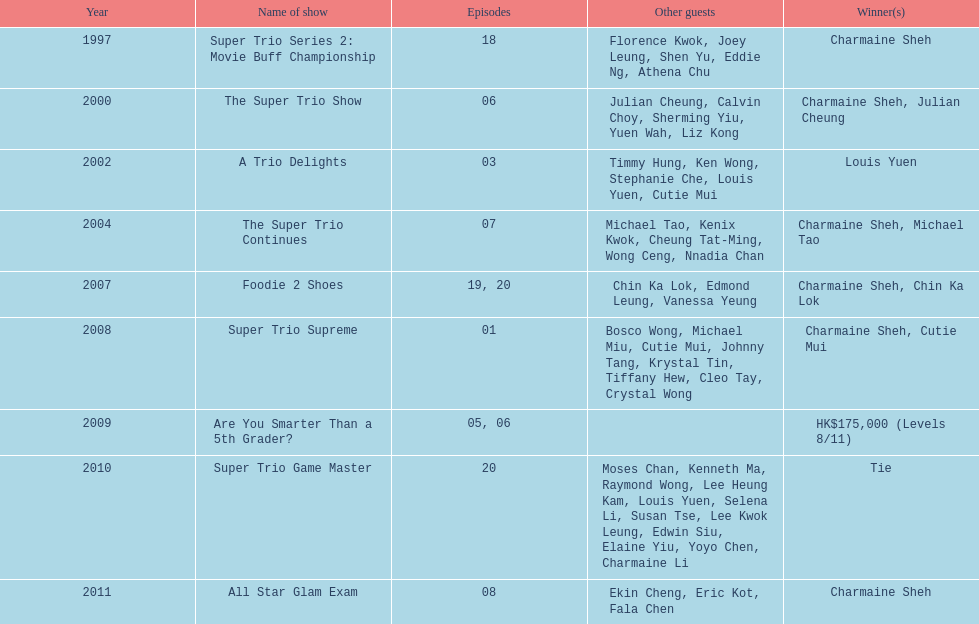What is the duration since charmaine sheh initially made an appearance on a variety show? 17 years. 